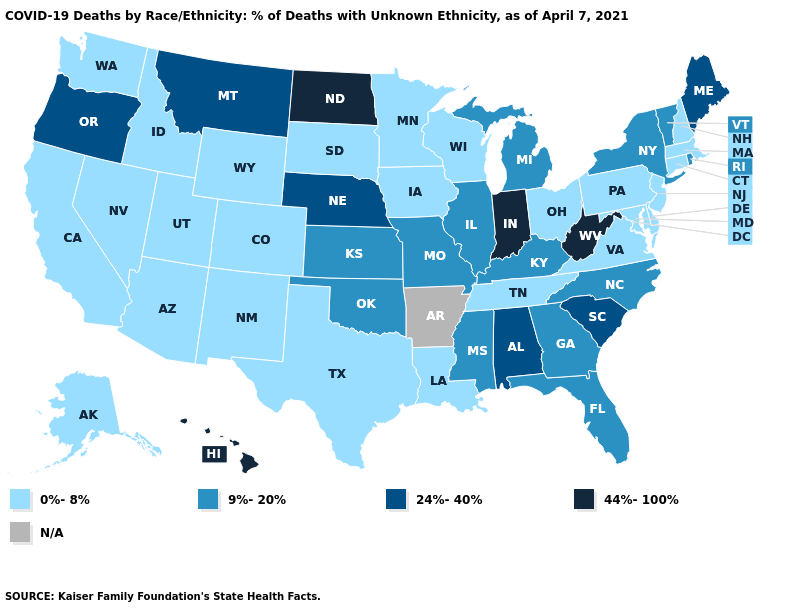Does Texas have the highest value in the USA?
Concise answer only. No. Is the legend a continuous bar?
Be succinct. No. What is the highest value in the USA?
Concise answer only. 44%-100%. Which states have the lowest value in the USA?
Quick response, please. Alaska, Arizona, California, Colorado, Connecticut, Delaware, Idaho, Iowa, Louisiana, Maryland, Massachusetts, Minnesota, Nevada, New Hampshire, New Jersey, New Mexico, Ohio, Pennsylvania, South Dakota, Tennessee, Texas, Utah, Virginia, Washington, Wisconsin, Wyoming. What is the highest value in the USA?
Concise answer only. 44%-100%. What is the highest value in the USA?
Keep it brief. 44%-100%. What is the value of South Dakota?
Short answer required. 0%-8%. What is the value of Kansas?
Quick response, please. 9%-20%. Among the states that border North Carolina , does Virginia have the lowest value?
Keep it brief. Yes. What is the lowest value in the South?
Short answer required. 0%-8%. Among the states that border Kansas , which have the lowest value?
Be succinct. Colorado. Does Michigan have the lowest value in the USA?
Answer briefly. No. Does South Dakota have the highest value in the MidWest?
Give a very brief answer. No. What is the highest value in states that border Ohio?
Write a very short answer. 44%-100%. 